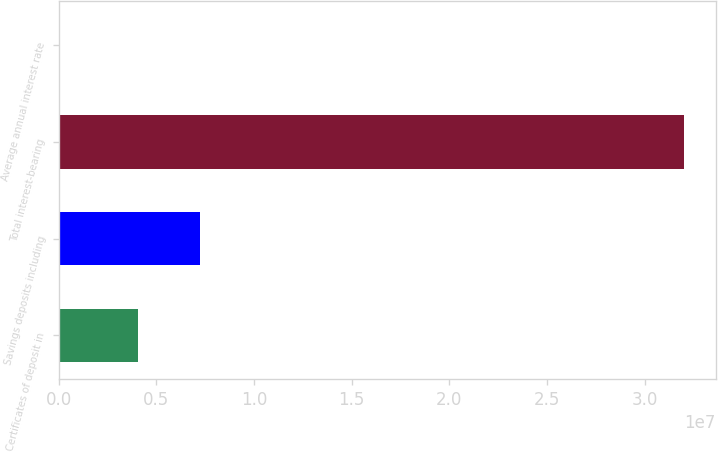<chart> <loc_0><loc_0><loc_500><loc_500><bar_chart><fcel>Certificates of deposit in<fcel>Savings deposits including<fcel>Total interest-bearing<fcel>Average annual interest rate<nl><fcel>4.04795e+06<fcel>7.2508e+06<fcel>3.20285e+07<fcel>3.94<nl></chart> 